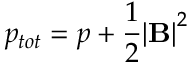Convert formula to latex. <formula><loc_0><loc_0><loc_500><loc_500>p _ { t o t } = p + \frac { 1 } { 2 } { | B | } ^ { 2 }</formula> 